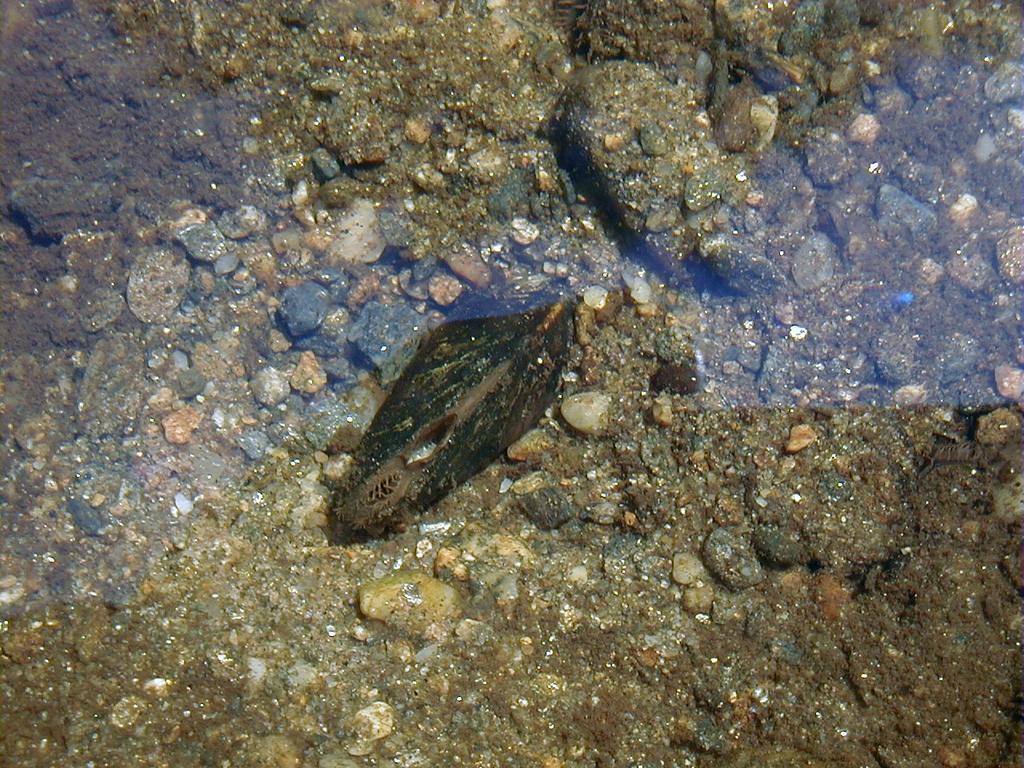In one or two sentences, can you explain what this image depicts? In the picture I can see an animal in the water. Here I can see few stones in the water. 